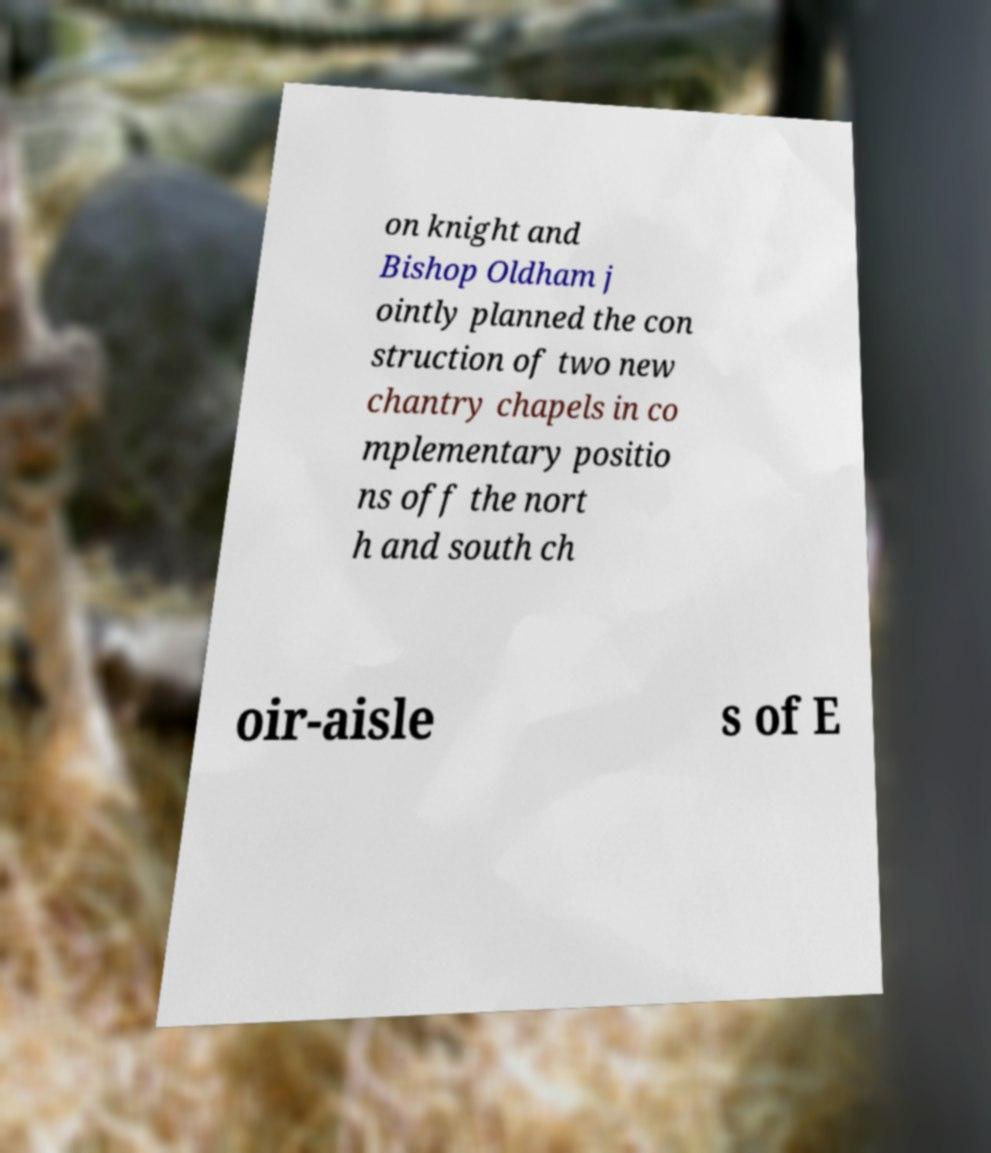I need the written content from this picture converted into text. Can you do that? on knight and Bishop Oldham j ointly planned the con struction of two new chantry chapels in co mplementary positio ns off the nort h and south ch oir-aisle s of E 